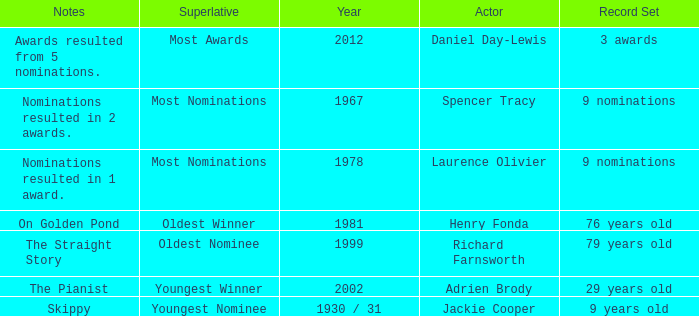What are the notes in 1981? On Golden Pond. 